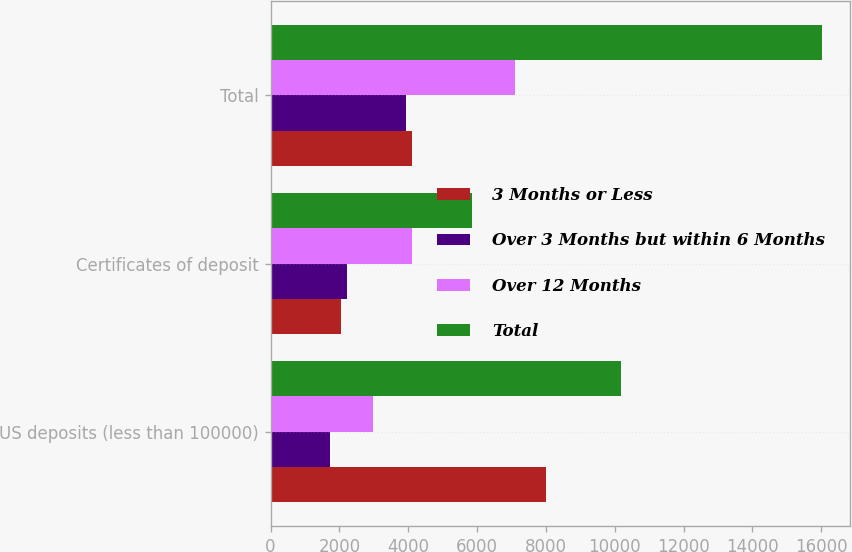<chart> <loc_0><loc_0><loc_500><loc_500><stacked_bar_chart><ecel><fcel>US deposits (less than 100000)<fcel>Certificates of deposit<fcel>Total<nl><fcel>3 Months or Less<fcel>8001<fcel>2059<fcel>4112<nl><fcel>Over 3 Months but within 6 Months<fcel>1737<fcel>2207<fcel>3944<nl><fcel>Over 12 Months<fcel>2976<fcel>4112<fcel>7088<nl><fcel>Total<fcel>10185<fcel>5844<fcel>16029<nl></chart> 